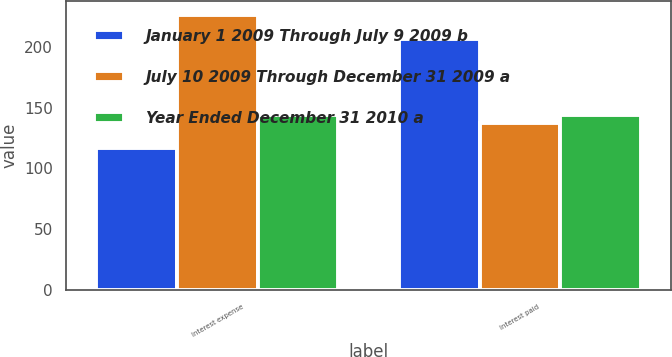<chart> <loc_0><loc_0><loc_500><loc_500><stacked_bar_chart><ecel><fcel>Interest expense<fcel>Interest paid<nl><fcel>January 1 2009 Through July 9 2009 b<fcel>117<fcel>206<nl><fcel>July 10 2009 Through December 31 2009 a<fcel>226<fcel>137<nl><fcel>Year Ended December 31 2010 a<fcel>144<fcel>144<nl></chart> 